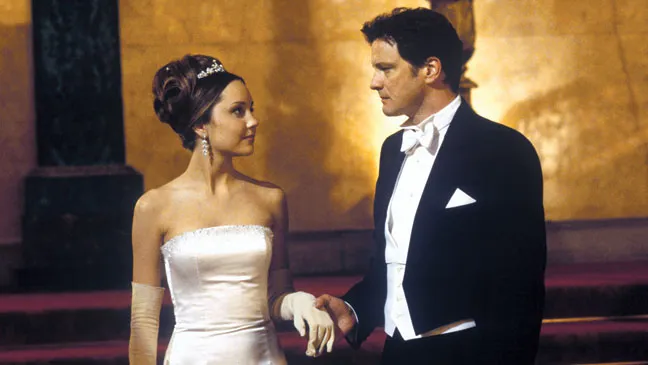Let's get creative! What if the setting were a futuristic sci-fi world? In a futuristic sci-fi world, Amanda Bynes’ character could be a diplomat from an interstellar coalition, adorned in an advanced ceremonial suit with glowing energy bands instead of a gown, symbolizing the united planets she represents. The tiara might be a sophisticated neural interface that allows her to communicate with diverse alien species. Colin Firth's character could be a high-ranking officer in a space fleet, his uniform equipped with advanced technology for tactical operations. The gold background could be the hull of a grand spaceship hosting a critical intergalactic summit. As they stand together, ready to address representatives from various galaxies, the gravity of their mission reflects on their faces. They're not just attending an important event; they're on the brink of negotiating peace in a universe teetering on the edge of war. Their interaction catches a fleeting, human moment amidst the vast expanse of space diplomacy. What if the characters were in an animated forest meeting magical creatures? In an animated forest filled with vibrant, magical creatures, Amanda Bynes’ character could be a fairy princess, her gown seamlessly blending with her ethereal wings that shimmer under the forest's magical light. The tiara could be made of glowing flowers gifted by the forest spirits. Colin Firth's character could be a noble forest guardian, sworn to protect the enchanted woods and its inhabitants, his attire a blend of natural elements and ancient armor crafted by woodland smiths. The gold background could represent the enchanted glow of the forest's heart, a sacred place where magic thrives. As they stand together, the atmosphere is filled with the sounds of mystical creatures and the rustling of ancient trees. They might be on the brink of a critical alliance with the forest’s magical beings to protect their world from an encroaching darkness, their expressions reflecting their commitment and the enchantment surrounding them. 